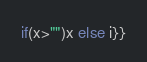<code> <loc_0><loc_0><loc_500><loc_500><_Scala_>if(x>"")x else i}}</code> 